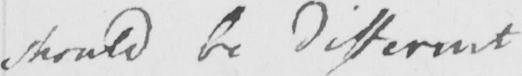Can you tell me what this handwritten text says? should be different 